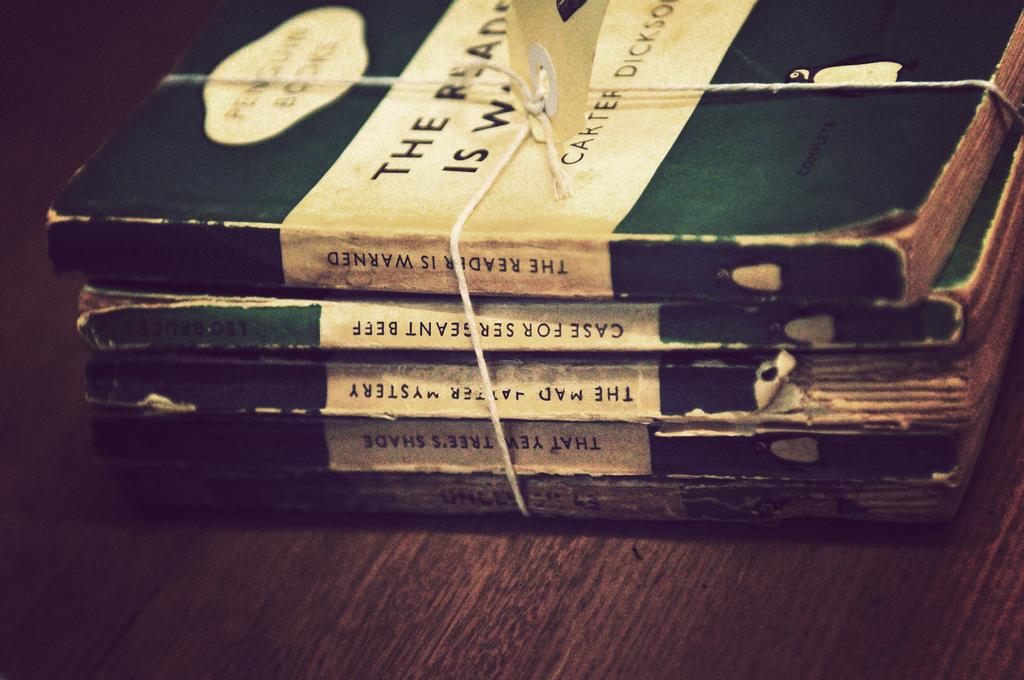<image>
Present a compact description of the photo's key features. Five old paperbacks are bundled with string, including Case For Sergeant Beef. 